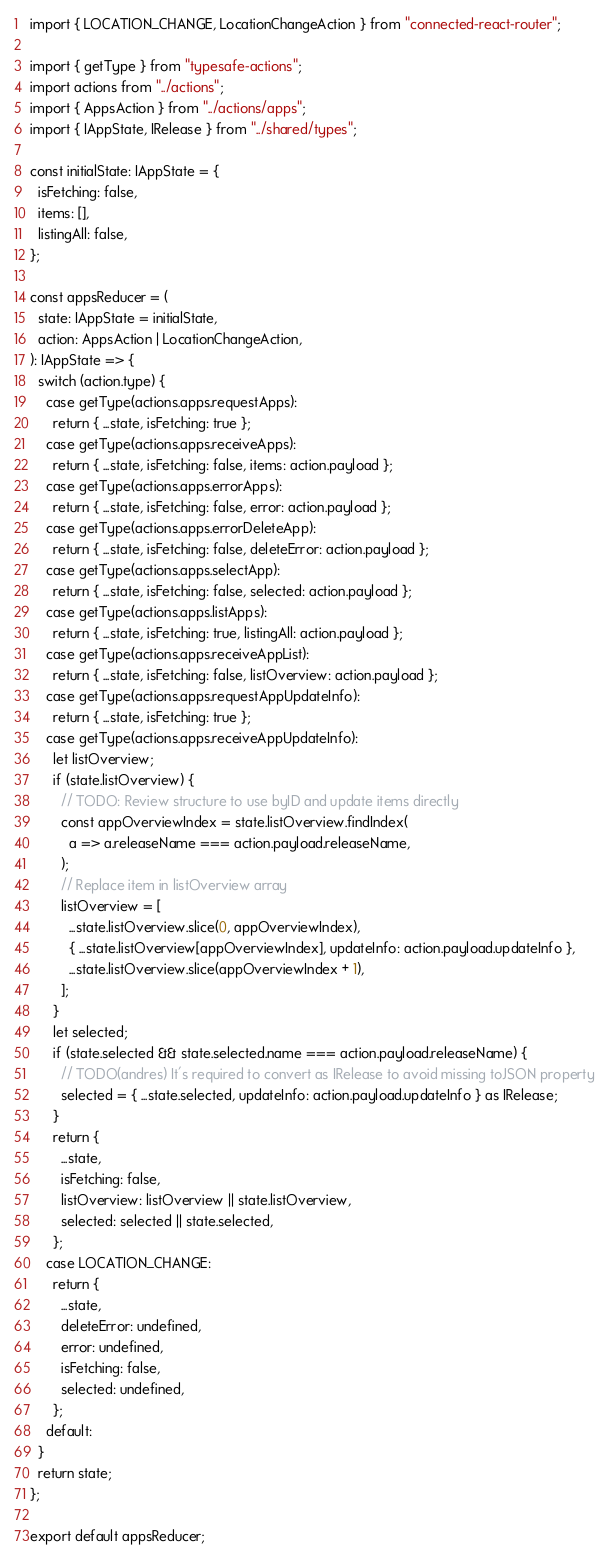Convert code to text. <code><loc_0><loc_0><loc_500><loc_500><_TypeScript_>import { LOCATION_CHANGE, LocationChangeAction } from "connected-react-router";

import { getType } from "typesafe-actions";
import actions from "../actions";
import { AppsAction } from "../actions/apps";
import { IAppState, IRelease } from "../shared/types";

const initialState: IAppState = {
  isFetching: false,
  items: [],
  listingAll: false,
};

const appsReducer = (
  state: IAppState = initialState,
  action: AppsAction | LocationChangeAction,
): IAppState => {
  switch (action.type) {
    case getType(actions.apps.requestApps):
      return { ...state, isFetching: true };
    case getType(actions.apps.receiveApps):
      return { ...state, isFetching: false, items: action.payload };
    case getType(actions.apps.errorApps):
      return { ...state, isFetching: false, error: action.payload };
    case getType(actions.apps.errorDeleteApp):
      return { ...state, isFetching: false, deleteError: action.payload };
    case getType(actions.apps.selectApp):
      return { ...state, isFetching: false, selected: action.payload };
    case getType(actions.apps.listApps):
      return { ...state, isFetching: true, listingAll: action.payload };
    case getType(actions.apps.receiveAppList):
      return { ...state, isFetching: false, listOverview: action.payload };
    case getType(actions.apps.requestAppUpdateInfo):
      return { ...state, isFetching: true };
    case getType(actions.apps.receiveAppUpdateInfo):
      let listOverview;
      if (state.listOverview) {
        // TODO: Review structure to use byID and update items directly
        const appOverviewIndex = state.listOverview.findIndex(
          a => a.releaseName === action.payload.releaseName,
        );
        // Replace item in listOverview array
        listOverview = [
          ...state.listOverview.slice(0, appOverviewIndex),
          { ...state.listOverview[appOverviewIndex], updateInfo: action.payload.updateInfo },
          ...state.listOverview.slice(appOverviewIndex + 1),
        ];
      }
      let selected;
      if (state.selected && state.selected.name === action.payload.releaseName) {
        // TODO(andres) It's required to convert as IRelease to avoid missing toJSON property
        selected = { ...state.selected, updateInfo: action.payload.updateInfo } as IRelease;
      }
      return {
        ...state,
        isFetching: false,
        listOverview: listOverview || state.listOverview,
        selected: selected || state.selected,
      };
    case LOCATION_CHANGE:
      return {
        ...state,
        deleteError: undefined,
        error: undefined,
        isFetching: false,
        selected: undefined,
      };
    default:
  }
  return state;
};

export default appsReducer;
</code> 